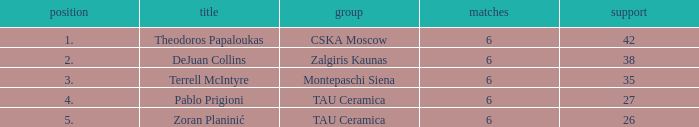What is the least number of assists among players ranked 2? 38.0. 